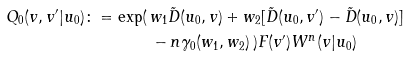Convert formula to latex. <formula><loc_0><loc_0><loc_500><loc_500>Q _ { 0 } ( v , v ^ { \prime } | u _ { 0 } ) \colon = \exp ( \, & w _ { 1 } \tilde { D } ( u _ { 0 } , v ) + w _ { 2 } [ \tilde { D } ( u _ { 0 } , v ^ { \prime } ) - \tilde { D } ( u _ { 0 } , v ) ] \\ & - n \gamma _ { 0 } ( w _ { 1 } , w _ { 2 } ) \, ) F ( v ^ { \prime } ) W ^ { n } ( v | u _ { 0 } )</formula> 